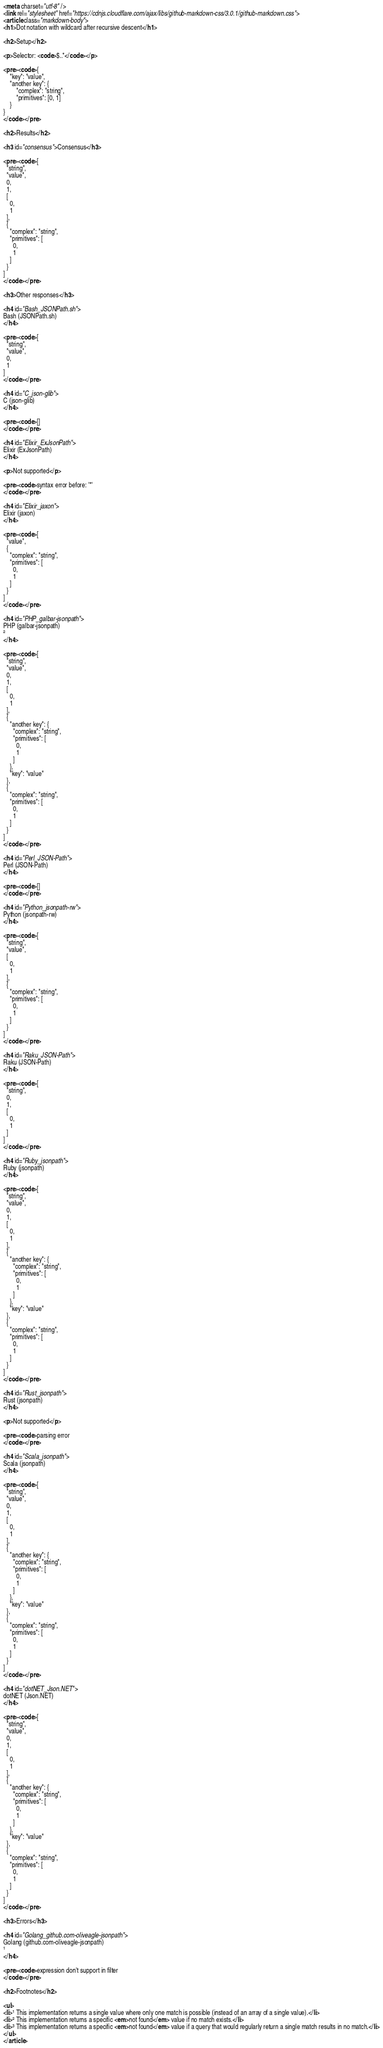<code> <loc_0><loc_0><loc_500><loc_500><_HTML_><meta charset="utf-8" />
<link rel="stylesheet" href="https://cdnjs.cloudflare.com/ajax/libs/github-markdown-css/3.0.1/github-markdown.css">
<article class="markdown-body">
<h1>Dot notation with wildcard after recursive descent</h1>

<h2>Setup</h2>

<p>Selector: <code>$..*</code></p>

<pre><code>{
    "key": "value",
    "another key": {
        "complex": "string",
        "primitives": [0, 1]
    }
}
</code></pre>

<h2>Results</h2>

<h3 id="consensus">Consensus</h3>

<pre><code>[
  "string",
  "value",
  0,
  1,
  [
    0,
    1
  ],
  {
    "complex": "string",
    "primitives": [
      0,
      1
    ]
  }
]
</code></pre>

<h3>Other responses</h3>

<h4 id="Bash_JSONPath.sh">
Bash (JSONPath.sh)
</h4>

<pre><code>[
  "string",
  "value",
  0,
  1
]
</code></pre>

<h4 id="C_json-glib">
C (json-glib)
</h4>

<pre><code>[]
</code></pre>

<h4 id="Elixir_ExJsonPath">
Elixir (ExJsonPath)
</h4>

<p>Not supported</p>

<pre><code>syntax error before: '*'
</code></pre>

<h4 id="Elixir_jaxon">
Elixir (jaxon)
</h4>

<pre><code>[
  "value",
  {
    "complex": "string",
    "primitives": [
      0,
      1
    ]
  }
]
</code></pre>

<h4 id="PHP_galbar-jsonpath">
PHP (galbar-jsonpath)
²
</h4>

<pre><code>[
  "string",
  "value",
  0,
  1,
  [
    0,
    1
  ],
  {
    "another key": {
      "complex": "string",
      "primitives": [
        0,
        1
      ]
    },
    "key": "value"
  },
  {
    "complex": "string",
    "primitives": [
      0,
      1
    ]
  }
]
</code></pre>

<h4 id="Perl_JSON-Path">
Perl (JSON-Path)
</h4>

<pre><code>[]
</code></pre>

<h4 id="Python_jsonpath-rw">
Python (jsonpath-rw)
</h4>

<pre><code>[
  "string",
  "value",
  [
    0,
    1
  ],
  {
    "complex": "string",
    "primitives": [
      0,
      1
    ]
  }
]
</code></pre>

<h4 id="Raku_JSON-Path">
Raku (JSON-Path)
</h4>

<pre><code>[
  "string",
  0,
  1,
  [
    0,
    1
  ]
]
</code></pre>

<h4 id="Ruby_jsonpath">
Ruby (jsonpath)
</h4>

<pre><code>[
  "string",
  "value",
  0,
  1,
  [
    0,
    1
  ],
  {
    "another key": {
      "complex": "string",
      "primitives": [
        0,
        1
      ]
    },
    "key": "value"
  },
  {
    "complex": "string",
    "primitives": [
      0,
      1
    ]
  }
]
</code></pre>

<h4 id="Rust_jsonpath">
Rust (jsonpath)
</h4>

<p>Not supported</p>

<pre><code>parsing error
</code></pre>

<h4 id="Scala_jsonpath">
Scala (jsonpath)
</h4>

<pre><code>[
  "string",
  "value",
  0,
  1,
  [
    0,
    1
  ],
  {
    "another key": {
      "complex": "string",
      "primitives": [
        0,
        1
      ]
    },
    "key": "value"
  },
  {
    "complex": "string",
    "primitives": [
      0,
      1
    ]
  }
]
</code></pre>

<h4 id="dotNET_Json.NET">
dotNET (Json.NET)
</h4>

<pre><code>[
  "string",
  "value",
  0,
  1,
  [
    0,
    1
  ],
  {
    "another key": {
      "complex": "string",
      "primitives": [
        0,
        1
      ]
    },
    "key": "value"
  },
  {
    "complex": "string",
    "primitives": [
      0,
      1
    ]
  }
]
</code></pre>

<h3>Errors</h3>

<h4 id="Golang_github.com-oliveagle-jsonpath">
Golang (github.com-oliveagle-jsonpath)
¹
</h4>

<pre><code>expression don't support in filter
</code></pre>

<h2>Footnotes</h2>

<ul>
<li>¹ This implementation returns a single value where only one match is possible (instead of an array of a single value).</li>
<li>² This implementation returns a specific <em>not found</em> value if no match exists.</li>
<li>³ This implementation returns a specific <em>not found</em> value if a query that would regularly return a single match results in no match.</li>
</ul>
</article></code> 